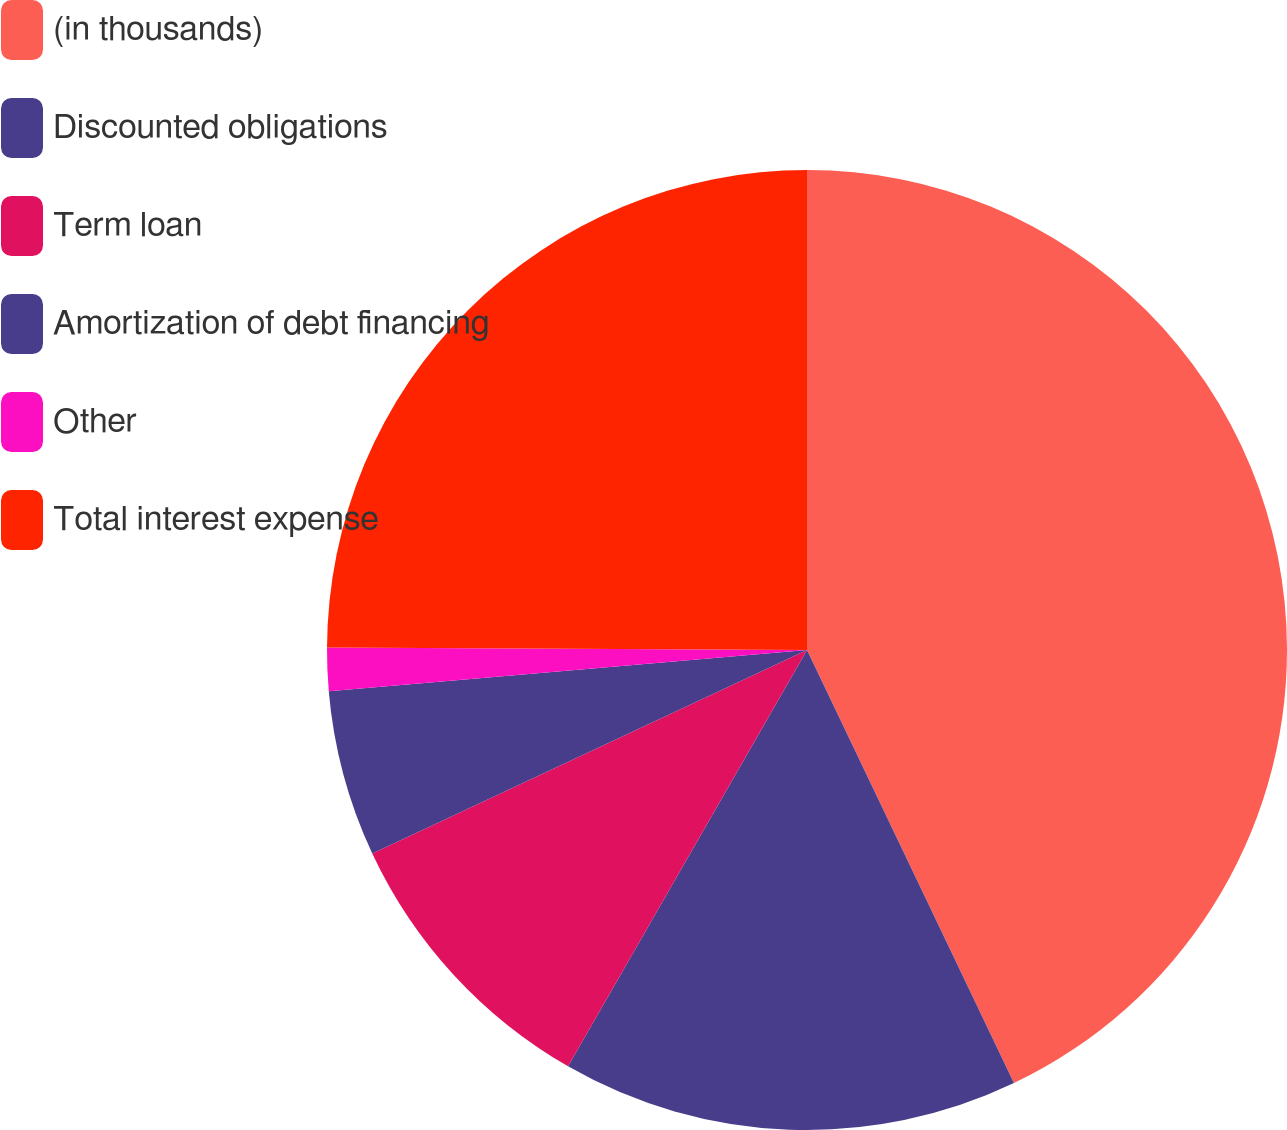<chart> <loc_0><loc_0><loc_500><loc_500><pie_chart><fcel>(in thousands)<fcel>Discounted obligations<fcel>Term loan<fcel>Amortization of debt financing<fcel>Other<fcel>Total interest expense<nl><fcel>42.91%<fcel>15.39%<fcel>9.74%<fcel>5.6%<fcel>1.45%<fcel>24.92%<nl></chart> 